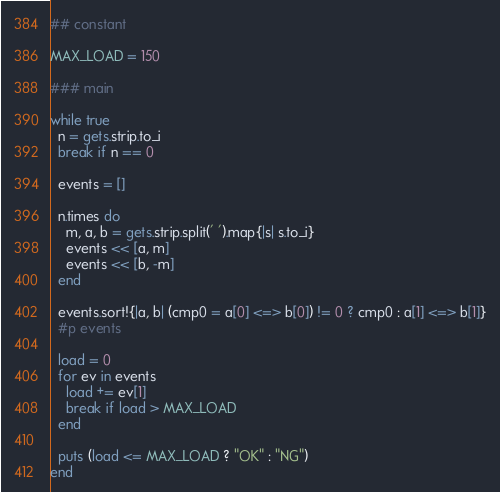<code> <loc_0><loc_0><loc_500><loc_500><_Ruby_>## constant

MAX_LOAD = 150

### main

while true
  n = gets.strip.to_i
  break if n == 0

  events = []

  n.times do
    m, a, b = gets.strip.split(' ').map{|s| s.to_i}
    events << [a, m]
    events << [b, -m]
  end

  events.sort!{|a, b| (cmp0 = a[0] <=> b[0]) != 0 ? cmp0 : a[1] <=> b[1]}
  #p events

  load = 0
  for ev in events
    load += ev[1]
    break if load > MAX_LOAD
  end

  puts (load <= MAX_LOAD ? "OK" : "NG")
end</code> 